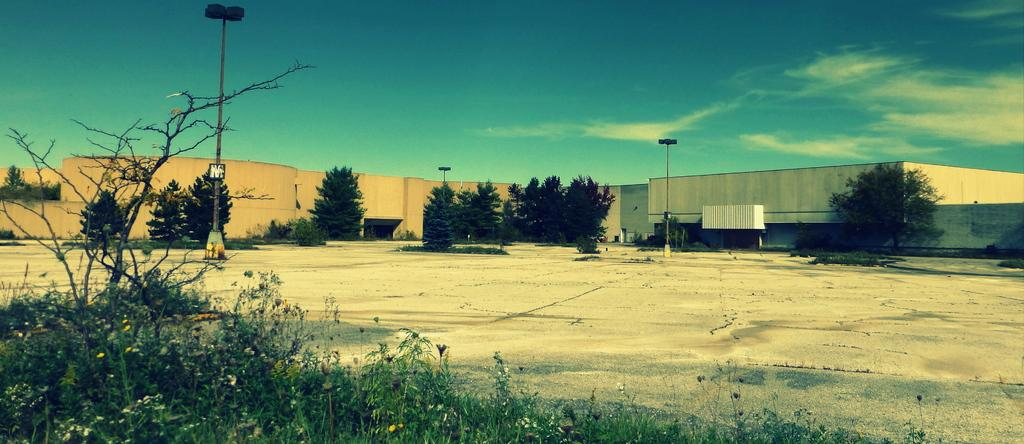What type of vegetation can be seen in the image? There are trees in the image. What structures are present in the image? There are poles and houses in the image. What is located in the front of the image? There are plants in the front of the image. What part of the natural environment is visible in the image? The sky is visible in the image. What can be seen in the sky? Clouds are present in the sky. What type of nail is being used to hold the sugar in the image? There is no nail or sugar present in the image. How many trucks can be seen in the image? There are no trucks present in the image. 